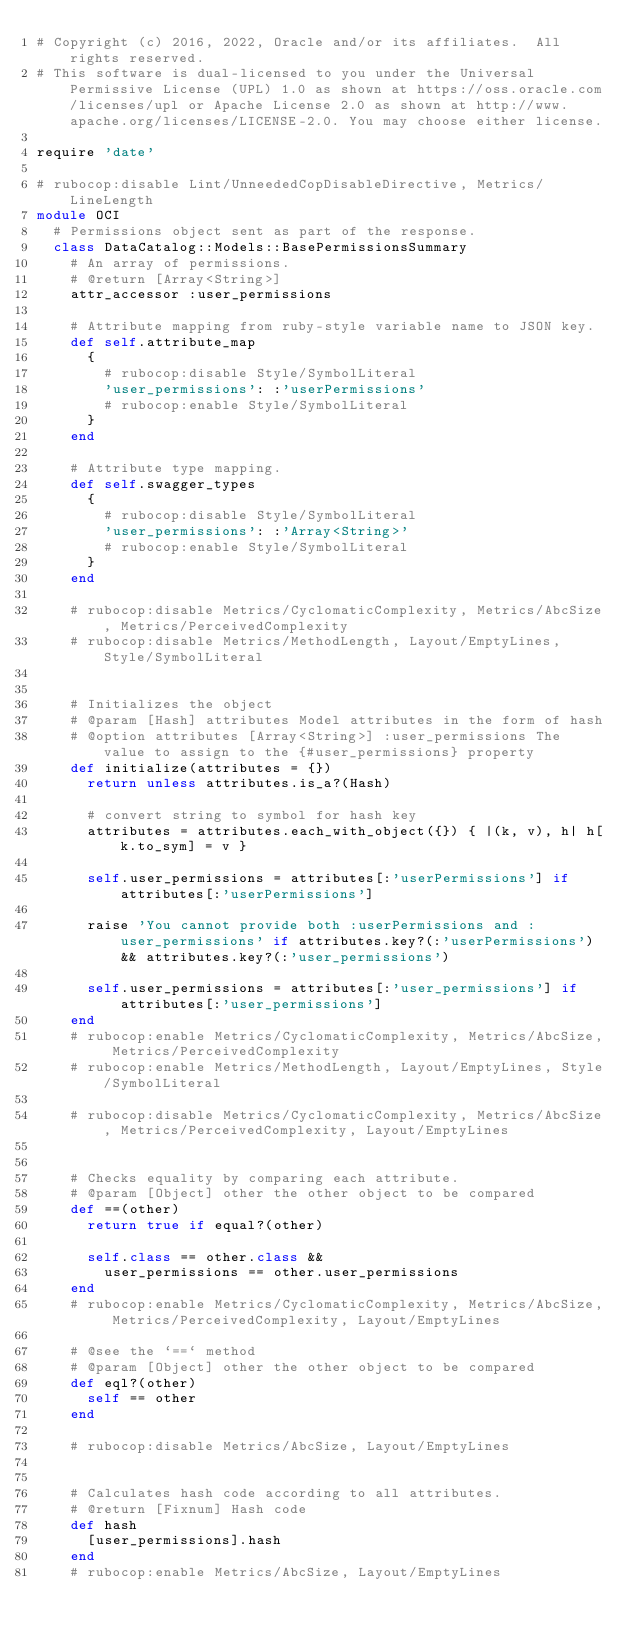Convert code to text. <code><loc_0><loc_0><loc_500><loc_500><_Ruby_># Copyright (c) 2016, 2022, Oracle and/or its affiliates.  All rights reserved.
# This software is dual-licensed to you under the Universal Permissive License (UPL) 1.0 as shown at https://oss.oracle.com/licenses/upl or Apache License 2.0 as shown at http://www.apache.org/licenses/LICENSE-2.0. You may choose either license.

require 'date'

# rubocop:disable Lint/UnneededCopDisableDirective, Metrics/LineLength
module OCI
  # Permissions object sent as part of the response.
  class DataCatalog::Models::BasePermissionsSummary
    # An array of permissions.
    # @return [Array<String>]
    attr_accessor :user_permissions

    # Attribute mapping from ruby-style variable name to JSON key.
    def self.attribute_map
      {
        # rubocop:disable Style/SymbolLiteral
        'user_permissions': :'userPermissions'
        # rubocop:enable Style/SymbolLiteral
      }
    end

    # Attribute type mapping.
    def self.swagger_types
      {
        # rubocop:disable Style/SymbolLiteral
        'user_permissions': :'Array<String>'
        # rubocop:enable Style/SymbolLiteral
      }
    end

    # rubocop:disable Metrics/CyclomaticComplexity, Metrics/AbcSize, Metrics/PerceivedComplexity
    # rubocop:disable Metrics/MethodLength, Layout/EmptyLines, Style/SymbolLiteral


    # Initializes the object
    # @param [Hash] attributes Model attributes in the form of hash
    # @option attributes [Array<String>] :user_permissions The value to assign to the {#user_permissions} property
    def initialize(attributes = {})
      return unless attributes.is_a?(Hash)

      # convert string to symbol for hash key
      attributes = attributes.each_with_object({}) { |(k, v), h| h[k.to_sym] = v }

      self.user_permissions = attributes[:'userPermissions'] if attributes[:'userPermissions']

      raise 'You cannot provide both :userPermissions and :user_permissions' if attributes.key?(:'userPermissions') && attributes.key?(:'user_permissions')

      self.user_permissions = attributes[:'user_permissions'] if attributes[:'user_permissions']
    end
    # rubocop:enable Metrics/CyclomaticComplexity, Metrics/AbcSize, Metrics/PerceivedComplexity
    # rubocop:enable Metrics/MethodLength, Layout/EmptyLines, Style/SymbolLiteral

    # rubocop:disable Metrics/CyclomaticComplexity, Metrics/AbcSize, Metrics/PerceivedComplexity, Layout/EmptyLines


    # Checks equality by comparing each attribute.
    # @param [Object] other the other object to be compared
    def ==(other)
      return true if equal?(other)

      self.class == other.class &&
        user_permissions == other.user_permissions
    end
    # rubocop:enable Metrics/CyclomaticComplexity, Metrics/AbcSize, Metrics/PerceivedComplexity, Layout/EmptyLines

    # @see the `==` method
    # @param [Object] other the other object to be compared
    def eql?(other)
      self == other
    end

    # rubocop:disable Metrics/AbcSize, Layout/EmptyLines


    # Calculates hash code according to all attributes.
    # @return [Fixnum] Hash code
    def hash
      [user_permissions].hash
    end
    # rubocop:enable Metrics/AbcSize, Layout/EmptyLines
</code> 